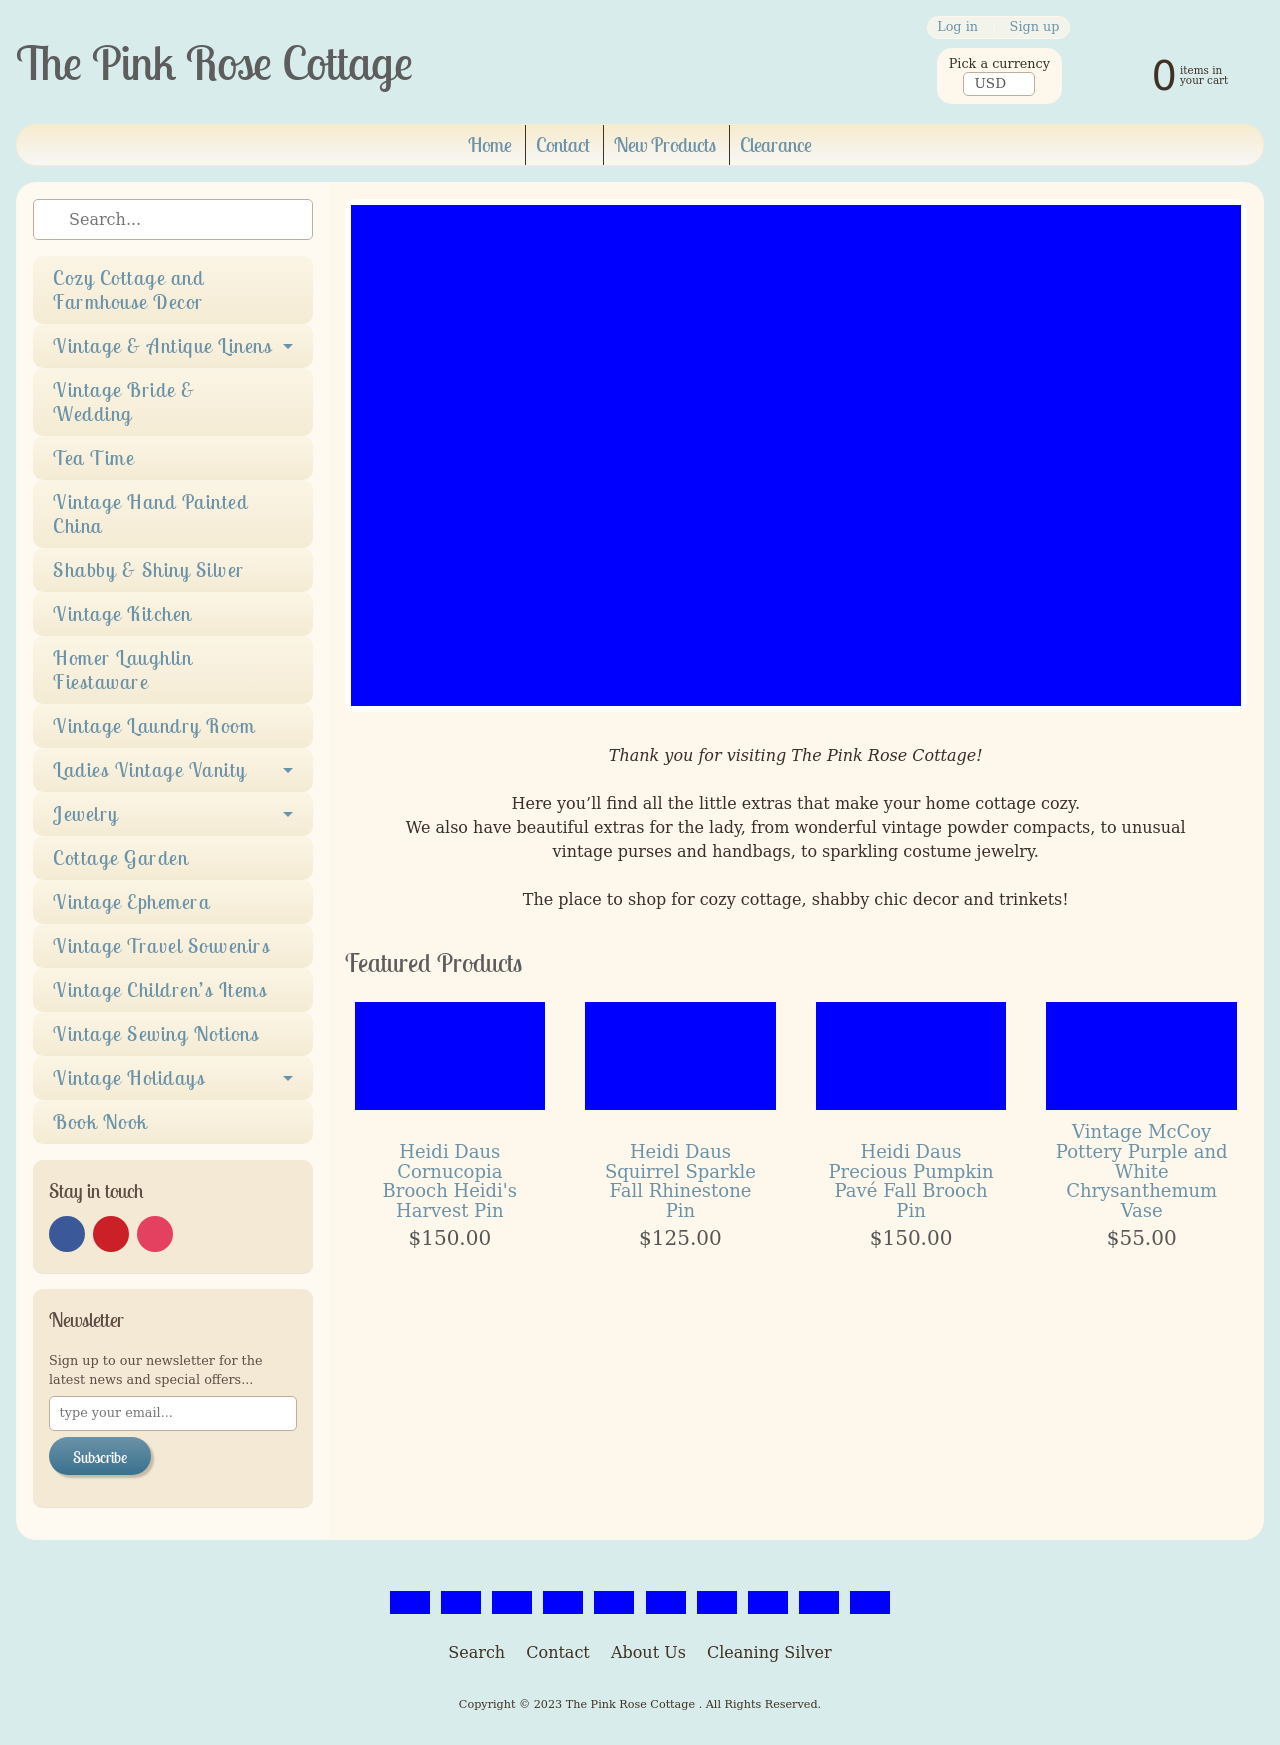What makes the 'Tea Time' category special at The Pink Rose Cottage? The 'Tea Time' category at The Pink Rose Cottage offers a charming assortment of vintage tea sets, teacups, and tea accessories. Each piece is carefully selected to ensure it represents the coziness and elegance of traditional English tea times, making them perfect for collectors or anyone looking to elevate their tea experience. Do they offer sets from specific historical periods? Absolutely, the collection includes items from various historical periods, including Victorian and Art Deco era pieces. Each set carries its own story and distinct craftsmanship that reflects the time period it originated from. 